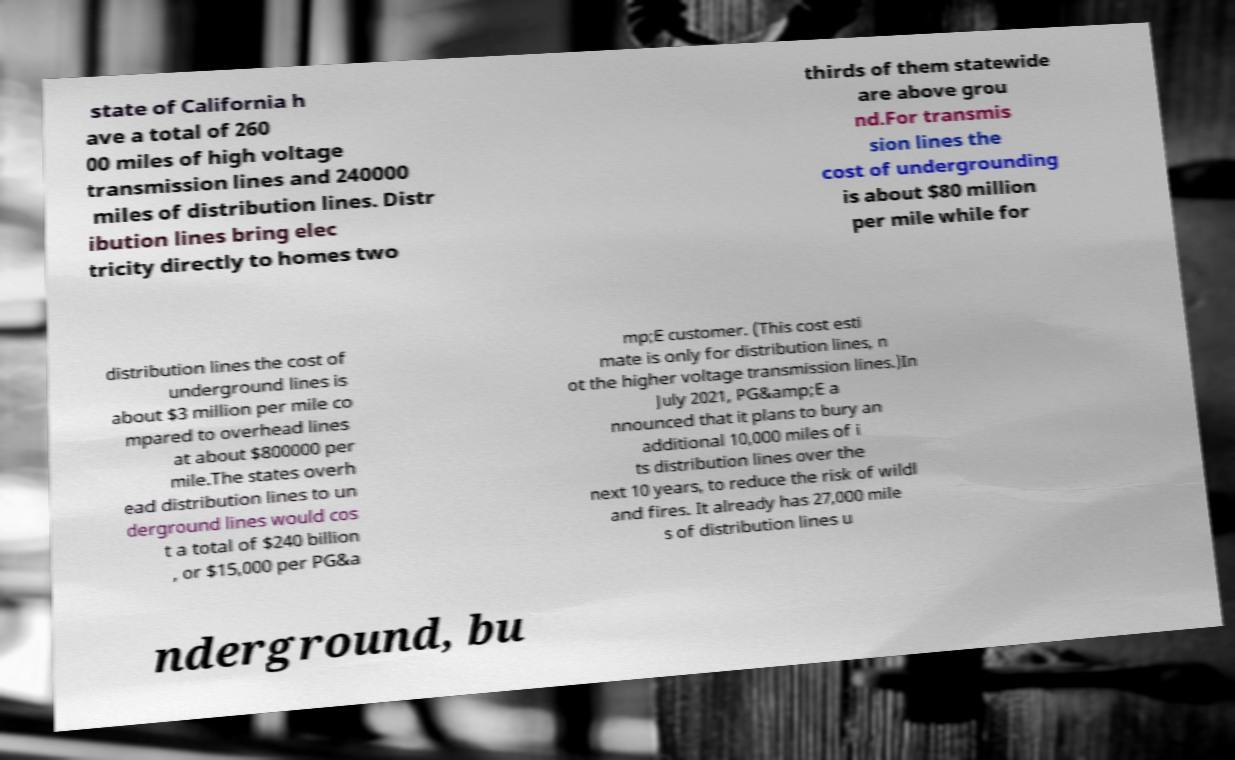Could you assist in decoding the text presented in this image and type it out clearly? state of California h ave a total of 260 00 miles of high voltage transmission lines and 240000 miles of distribution lines. Distr ibution lines bring elec tricity directly to homes two thirds of them statewide are above grou nd.For transmis sion lines the cost of undergrounding is about $80 million per mile while for distribution lines the cost of underground lines is about $3 million per mile co mpared to overhead lines at about $800000 per mile.The states overh ead distribution lines to un derground lines would cos t a total of $240 billion , or $15,000 per PG&a mp;E customer. (This cost esti mate is only for distribution lines, n ot the higher voltage transmission lines.)In July 2021, PG&amp;E a nnounced that it plans to bury an additional 10,000 miles of i ts distribution lines over the next 10 years, to reduce the risk of wildl and fires. It already has 27,000 mile s of distribution lines u nderground, bu 